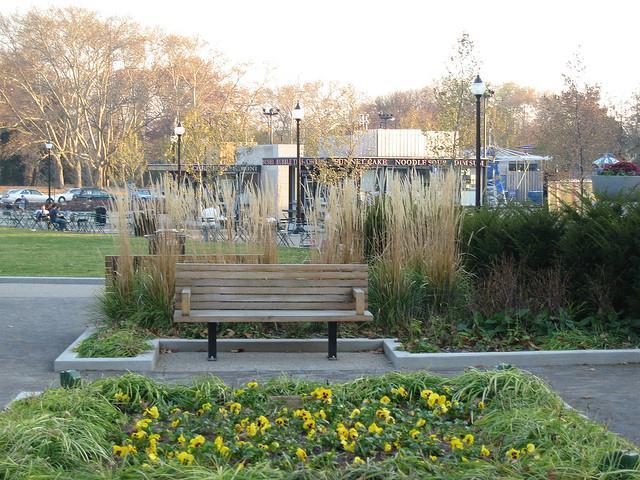How many light post are there?
Give a very brief answer. 4. How many places are there to sit?
Give a very brief answer. 2. 